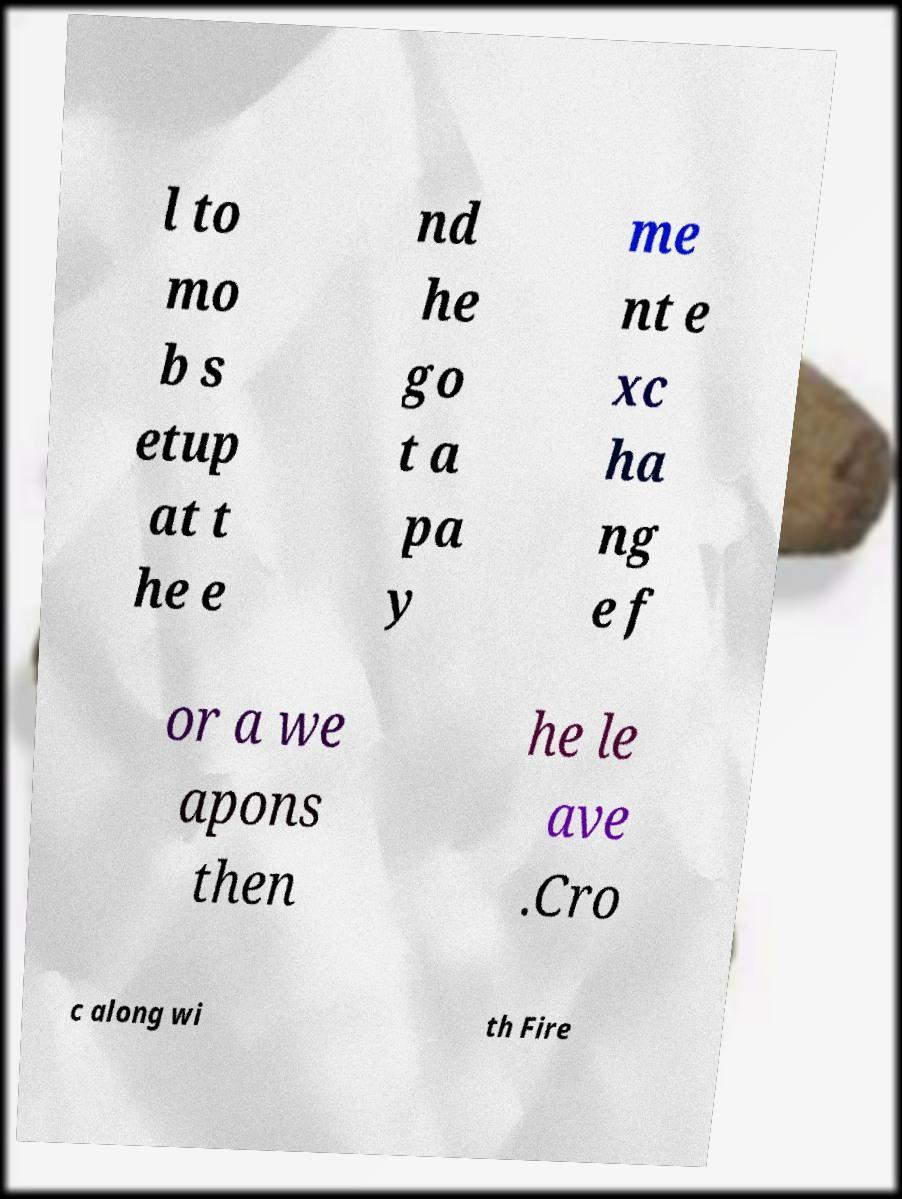Please identify and transcribe the text found in this image. l to mo b s etup at t he e nd he go t a pa y me nt e xc ha ng e f or a we apons then he le ave .Cro c along wi th Fire 